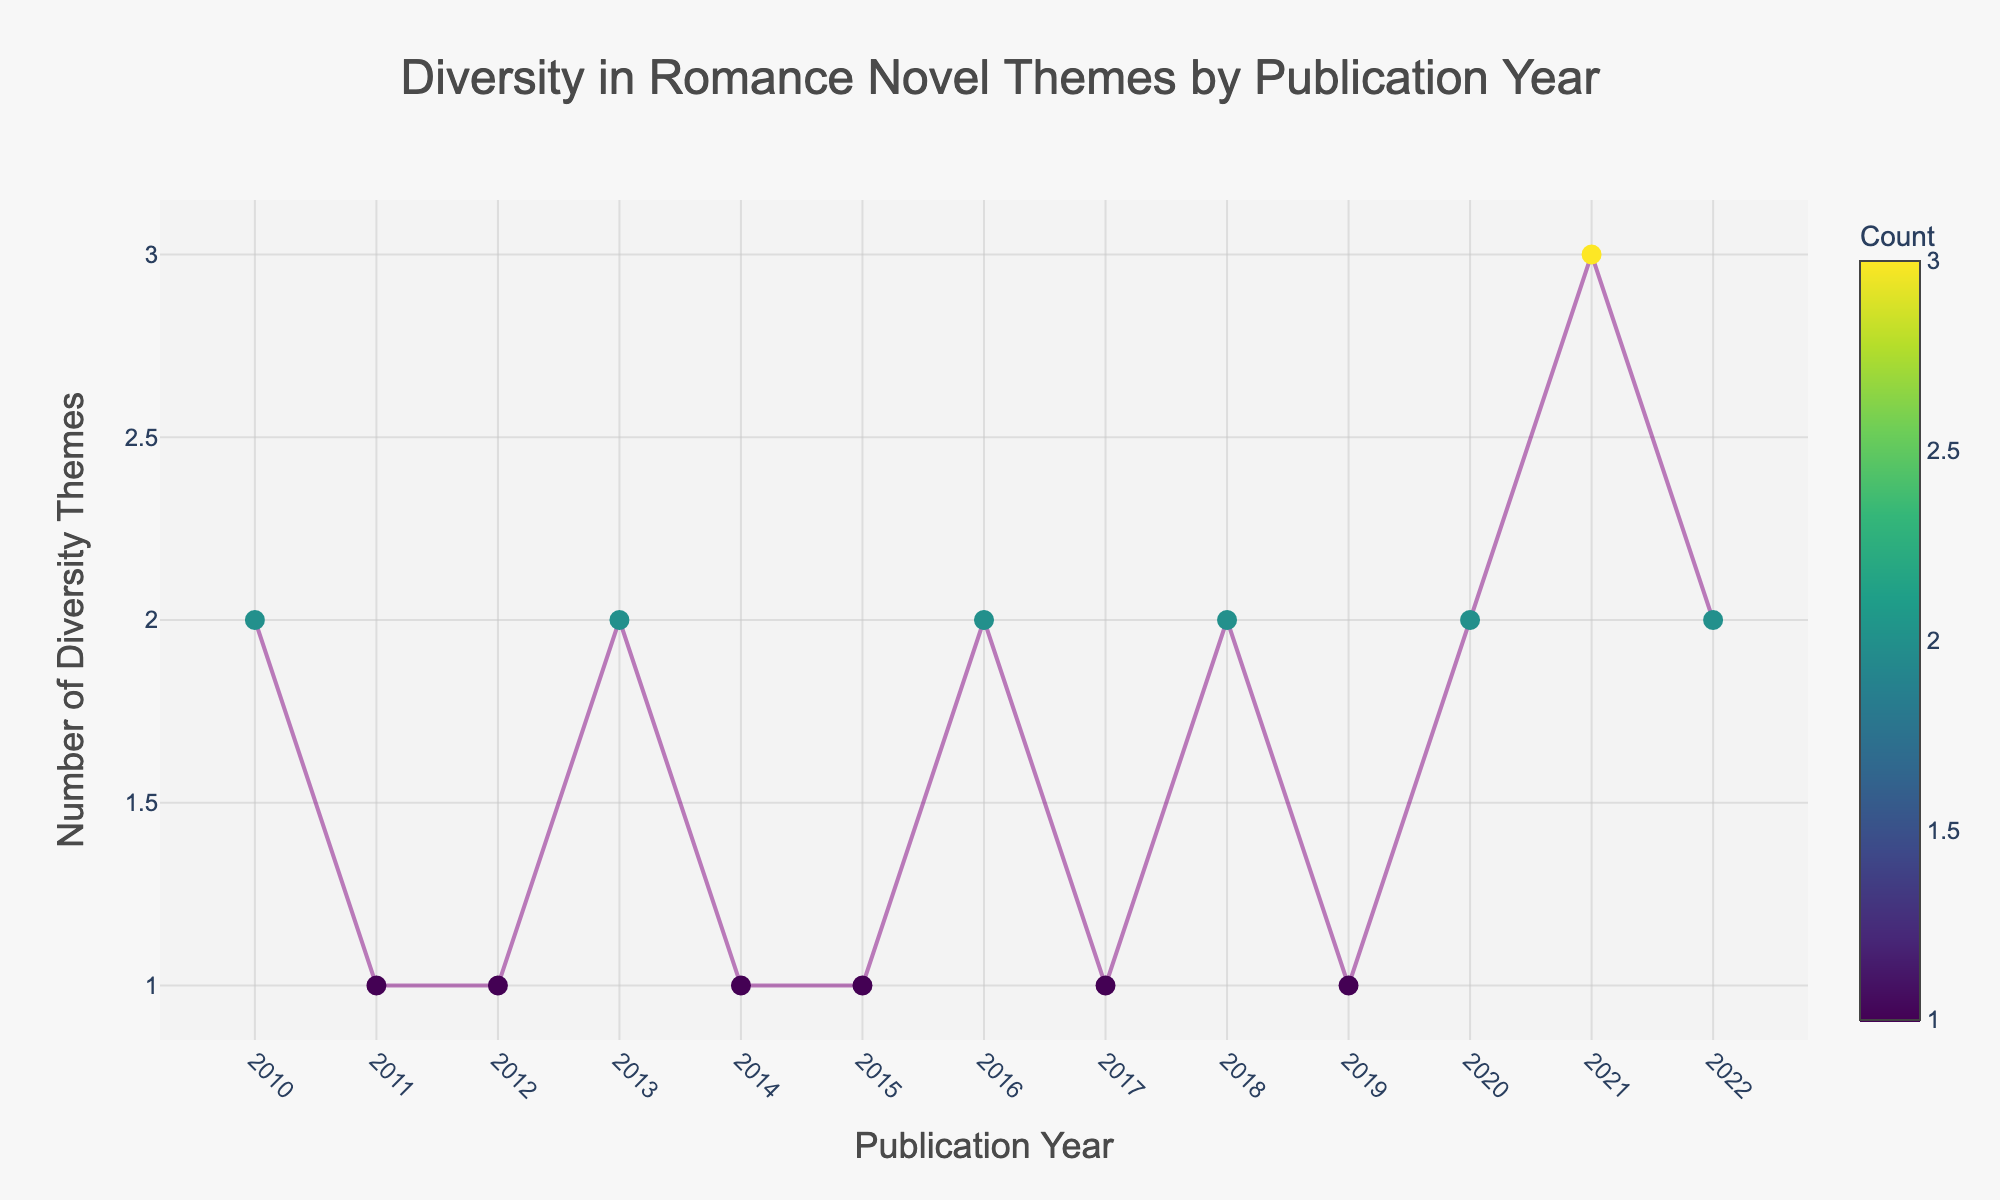What is the title of the plot? The title is usually located at the top of the figure and provides a brief description of what the figure represents. In this case, it is given as 'Diversity in Romance Novel Themes by Publication Year'.
Answer: Diversity in Romance Novel Themes by Publication Year What are the labels of the x and y axes? The x-axis represents 'Publication Year', and the y-axis represents 'Number of Diversity Themes'. These labels are indicated along the axes to show what each axis represents.
Answer: Publication Year and Number of Diversity Themes How many diversity themes were observed in 2021? By looking at the x-axis for the year 2021 and tracing it to the corresponding point on the figure, we see that the count for 2021 is highest with a marker and the count number is indicated by the color and size of the marker.
Answer: 3 Which year saw the introduction of the most diversity themes in romance novels? By observing the figure, we identify the year with the highest marker count and color intensity. The year with the most number of themes and a darker marker is 2021.
Answer: 2021 Compare the number of diversity themes introduced in 2010 and 2022. Which year had more? Observing the plot for the markers around these years, easily identify and compare their positions and marker sizes: in 2010, two themes were introduced, while in 2022, two themes were introduced as well. Both years have the same number of diversity themes.
Answer: Both had the same What was the trend in the number of diversity themes from 2014 to 2017? To understand the trend, observe the markers for these years: 2014 has 1, 2015 has 1, 2016 has 2, and 2017 has 1. The number initially increases from 2014 to 2016 and then decreases in 2017.
Answer: Increase then Decrease On average, how many diversity themes were introduced per year from 2018 to 2022? Sum the number of diversity themes from 2018 (2), 2019 (1), 2020 (2), 2021 (3), and 2022 (2). Then divide by the number of years, 5: (2 + 1 + 2 + 3 + 2)/5 = 10/5 = 2.
Answer: 2 Identify the year when the first indigenous perspectives theme was introduced. Trace the specific theme 'Indigenous Perspectives' across the figure to locate its first appearance, which occurs in the year 2016.
Answer: 2016 How does the number of diversity themes in 2016 compare to 2013? Observe the markers for these years: 2016 has two themes, as indicated by the marker count, and 2013 also has two themes. Thus, the number of diversity themes is the same in both years.
Answer: The same 